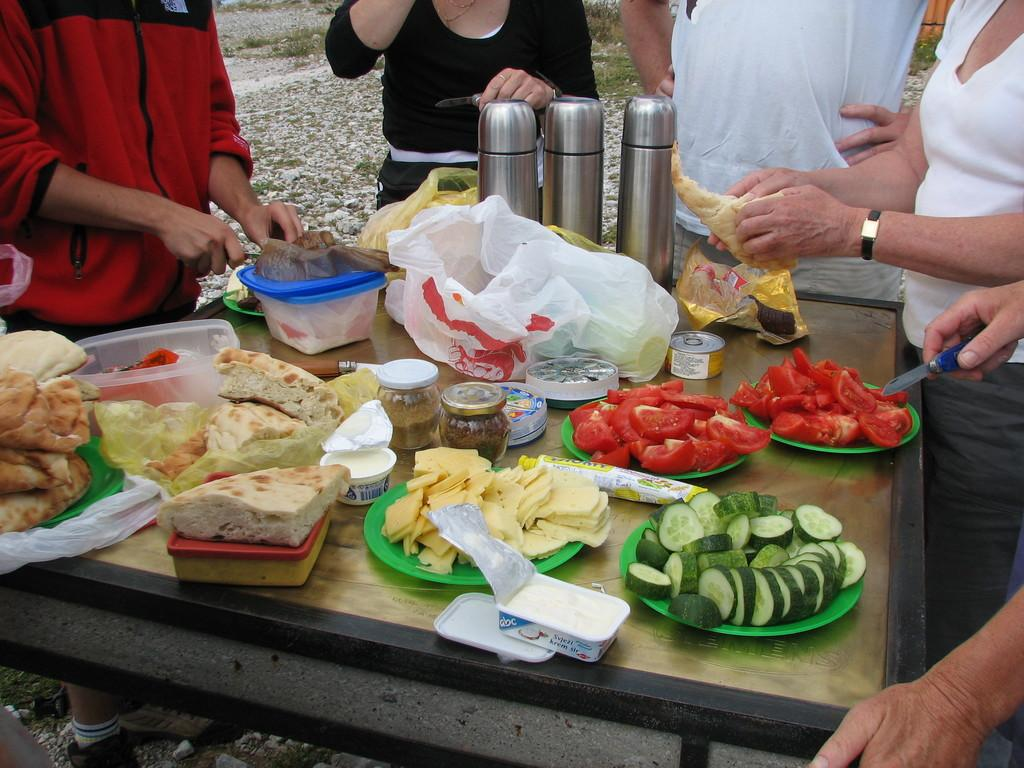What is the main object in the image? There is a table in the image. What is placed on the table? There are plates on the table. What is on the plates? The plates contain vegetables and other food items. How many people are present in the image? There are five persons standing around the table. What type of jail can be seen in the image? There is no jail present in the image; it features a table with plates containing food items and people standing around it. 